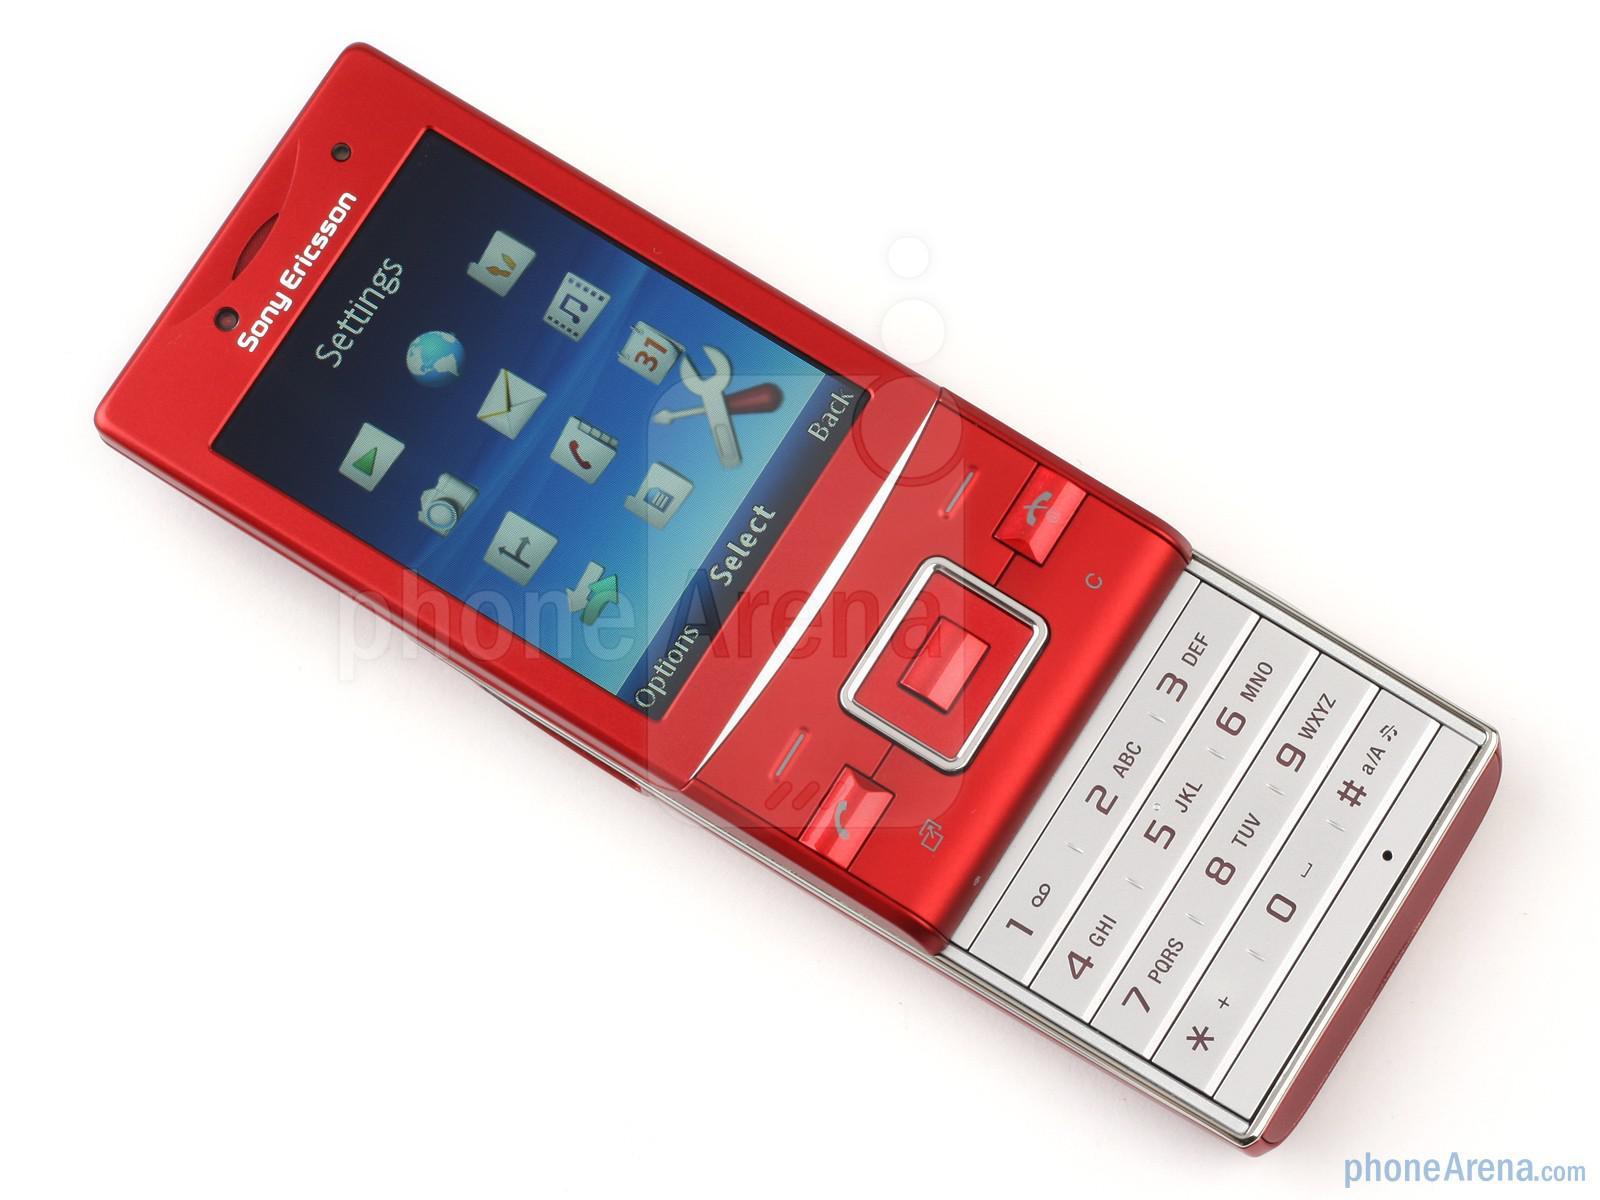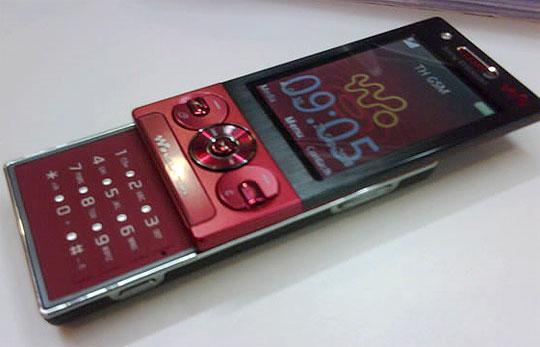The first image is the image on the left, the second image is the image on the right. Given the left and right images, does the statement "There are exactly two phones." hold true? Answer yes or no. Yes. The first image is the image on the left, the second image is the image on the right. Assess this claim about the two images: "There are only two phones.". Correct or not? Answer yes or no. Yes. 